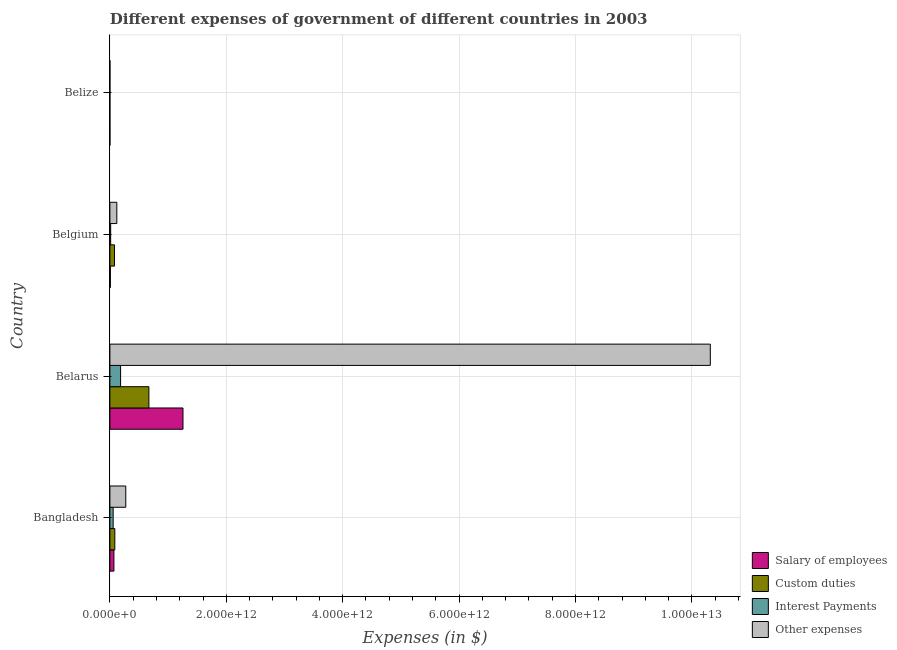How many bars are there on the 2nd tick from the top?
Offer a terse response. 4. What is the label of the 3rd group of bars from the top?
Make the answer very short. Belarus. What is the amount spent on salary of employees in Belize?
Provide a succinct answer. 1.91e+08. Across all countries, what is the maximum amount spent on other expenses?
Keep it short and to the point. 1.03e+13. Across all countries, what is the minimum amount spent on custom duties?
Give a very brief answer. 1.15e+08. In which country was the amount spent on other expenses maximum?
Make the answer very short. Belarus. In which country was the amount spent on custom duties minimum?
Make the answer very short. Belize. What is the total amount spent on other expenses in the graph?
Provide a succinct answer. 1.07e+13. What is the difference between the amount spent on salary of employees in Belarus and that in Belize?
Your answer should be very brief. 1.26e+12. What is the difference between the amount spent on custom duties in Belize and the amount spent on other expenses in Belarus?
Keep it short and to the point. -1.03e+13. What is the average amount spent on salary of employees per country?
Offer a terse response. 3.33e+11. What is the difference between the amount spent on salary of employees and amount spent on custom duties in Belarus?
Provide a succinct answer. 5.86e+11. In how many countries, is the amount spent on salary of employees greater than 2800000000000 $?
Provide a short and direct response. 0. What is the ratio of the amount spent on salary of employees in Belarus to that in Belize?
Make the answer very short. 6583.91. Is the difference between the amount spent on salary of employees in Belarus and Belgium greater than the difference between the amount spent on other expenses in Belarus and Belgium?
Your answer should be compact. No. What is the difference between the highest and the second highest amount spent on salary of employees?
Keep it short and to the point. 1.19e+12. What is the difference between the highest and the lowest amount spent on custom duties?
Your answer should be very brief. 6.70e+11. Is the sum of the amount spent on salary of employees in Bangladesh and Belgium greater than the maximum amount spent on interest payments across all countries?
Make the answer very short. No. What does the 4th bar from the top in Belarus represents?
Offer a terse response. Salary of employees. What does the 4th bar from the bottom in Belize represents?
Provide a succinct answer. Other expenses. Is it the case that in every country, the sum of the amount spent on salary of employees and amount spent on custom duties is greater than the amount spent on interest payments?
Your answer should be very brief. Yes. How many bars are there?
Give a very brief answer. 16. Are all the bars in the graph horizontal?
Keep it short and to the point. Yes. What is the difference between two consecutive major ticks on the X-axis?
Offer a very short reply. 2.00e+12. Does the graph contain any zero values?
Your response must be concise. No. Does the graph contain grids?
Offer a terse response. Yes. Where does the legend appear in the graph?
Make the answer very short. Bottom right. What is the title of the graph?
Provide a short and direct response. Different expenses of government of different countries in 2003. Does "Korea" appear as one of the legend labels in the graph?
Give a very brief answer. No. What is the label or title of the X-axis?
Your response must be concise. Expenses (in $). What is the label or title of the Y-axis?
Your response must be concise. Country. What is the Expenses (in $) in Salary of employees in Bangladesh?
Provide a succinct answer. 6.91e+1. What is the Expenses (in $) in Custom duties in Bangladesh?
Make the answer very short. 8.46e+1. What is the Expenses (in $) of Interest Payments in Bangladesh?
Make the answer very short. 5.62e+1. What is the Expenses (in $) in Other expenses in Bangladesh?
Offer a terse response. 2.73e+11. What is the Expenses (in $) in Salary of employees in Belarus?
Your answer should be very brief. 1.26e+12. What is the Expenses (in $) in Custom duties in Belarus?
Make the answer very short. 6.70e+11. What is the Expenses (in $) of Interest Payments in Belarus?
Provide a short and direct response. 1.84e+11. What is the Expenses (in $) in Other expenses in Belarus?
Your answer should be compact. 1.03e+13. What is the Expenses (in $) of Salary of employees in Belgium?
Keep it short and to the point. 8.32e+09. What is the Expenses (in $) in Custom duties in Belgium?
Provide a succinct answer. 7.95e+1. What is the Expenses (in $) in Interest Payments in Belgium?
Keep it short and to the point. 1.35e+1. What is the Expenses (in $) in Other expenses in Belgium?
Provide a succinct answer. 1.19e+11. What is the Expenses (in $) in Salary of employees in Belize?
Give a very brief answer. 1.91e+08. What is the Expenses (in $) in Custom duties in Belize?
Provide a short and direct response. 1.15e+08. What is the Expenses (in $) of Interest Payments in Belize?
Your answer should be compact. 8.13e+07. What is the Expenses (in $) of Other expenses in Belize?
Provide a short and direct response. 4.78e+08. Across all countries, what is the maximum Expenses (in $) of Salary of employees?
Offer a terse response. 1.26e+12. Across all countries, what is the maximum Expenses (in $) in Custom duties?
Provide a succinct answer. 6.70e+11. Across all countries, what is the maximum Expenses (in $) in Interest Payments?
Your answer should be compact. 1.84e+11. Across all countries, what is the maximum Expenses (in $) of Other expenses?
Provide a short and direct response. 1.03e+13. Across all countries, what is the minimum Expenses (in $) in Salary of employees?
Your answer should be very brief. 1.91e+08. Across all countries, what is the minimum Expenses (in $) of Custom duties?
Your answer should be compact. 1.15e+08. Across all countries, what is the minimum Expenses (in $) in Interest Payments?
Your answer should be very brief. 8.13e+07. Across all countries, what is the minimum Expenses (in $) of Other expenses?
Your answer should be compact. 4.78e+08. What is the total Expenses (in $) of Salary of employees in the graph?
Your response must be concise. 1.33e+12. What is the total Expenses (in $) of Custom duties in the graph?
Provide a short and direct response. 8.34e+11. What is the total Expenses (in $) in Interest Payments in the graph?
Provide a succinct answer. 2.54e+11. What is the total Expenses (in $) in Other expenses in the graph?
Ensure brevity in your answer.  1.07e+13. What is the difference between the Expenses (in $) in Salary of employees in Bangladesh and that in Belarus?
Your answer should be very brief. -1.19e+12. What is the difference between the Expenses (in $) of Custom duties in Bangladesh and that in Belarus?
Your answer should be very brief. -5.86e+11. What is the difference between the Expenses (in $) of Interest Payments in Bangladesh and that in Belarus?
Provide a short and direct response. -1.28e+11. What is the difference between the Expenses (in $) of Other expenses in Bangladesh and that in Belarus?
Provide a succinct answer. -1.00e+13. What is the difference between the Expenses (in $) in Salary of employees in Bangladesh and that in Belgium?
Offer a very short reply. 6.08e+1. What is the difference between the Expenses (in $) in Custom duties in Bangladesh and that in Belgium?
Give a very brief answer. 5.12e+09. What is the difference between the Expenses (in $) in Interest Payments in Bangladesh and that in Belgium?
Keep it short and to the point. 4.26e+1. What is the difference between the Expenses (in $) in Other expenses in Bangladesh and that in Belgium?
Give a very brief answer. 1.54e+11. What is the difference between the Expenses (in $) of Salary of employees in Bangladesh and that in Belize?
Offer a terse response. 6.89e+1. What is the difference between the Expenses (in $) of Custom duties in Bangladesh and that in Belize?
Offer a very short reply. 8.45e+1. What is the difference between the Expenses (in $) of Interest Payments in Bangladesh and that in Belize?
Provide a succinct answer. 5.61e+1. What is the difference between the Expenses (in $) of Other expenses in Bangladesh and that in Belize?
Give a very brief answer. 2.72e+11. What is the difference between the Expenses (in $) in Salary of employees in Belarus and that in Belgium?
Your answer should be compact. 1.25e+12. What is the difference between the Expenses (in $) in Custom duties in Belarus and that in Belgium?
Provide a succinct answer. 5.91e+11. What is the difference between the Expenses (in $) of Interest Payments in Belarus and that in Belgium?
Keep it short and to the point. 1.70e+11. What is the difference between the Expenses (in $) in Other expenses in Belarus and that in Belgium?
Offer a very short reply. 1.02e+13. What is the difference between the Expenses (in $) in Salary of employees in Belarus and that in Belize?
Offer a very short reply. 1.26e+12. What is the difference between the Expenses (in $) in Custom duties in Belarus and that in Belize?
Offer a very short reply. 6.70e+11. What is the difference between the Expenses (in $) in Interest Payments in Belarus and that in Belize?
Offer a very short reply. 1.84e+11. What is the difference between the Expenses (in $) in Other expenses in Belarus and that in Belize?
Your response must be concise. 1.03e+13. What is the difference between the Expenses (in $) of Salary of employees in Belgium and that in Belize?
Provide a succinct answer. 8.13e+09. What is the difference between the Expenses (in $) in Custom duties in Belgium and that in Belize?
Provide a succinct answer. 7.94e+1. What is the difference between the Expenses (in $) in Interest Payments in Belgium and that in Belize?
Your answer should be compact. 1.34e+1. What is the difference between the Expenses (in $) in Other expenses in Belgium and that in Belize?
Provide a succinct answer. 1.19e+11. What is the difference between the Expenses (in $) of Salary of employees in Bangladesh and the Expenses (in $) of Custom duties in Belarus?
Give a very brief answer. -6.01e+11. What is the difference between the Expenses (in $) in Salary of employees in Bangladesh and the Expenses (in $) in Interest Payments in Belarus?
Give a very brief answer. -1.15e+11. What is the difference between the Expenses (in $) of Salary of employees in Bangladesh and the Expenses (in $) of Other expenses in Belarus?
Your answer should be compact. -1.02e+13. What is the difference between the Expenses (in $) of Custom duties in Bangladesh and the Expenses (in $) of Interest Payments in Belarus?
Provide a short and direct response. -9.93e+1. What is the difference between the Expenses (in $) in Custom duties in Bangladesh and the Expenses (in $) in Other expenses in Belarus?
Make the answer very short. -1.02e+13. What is the difference between the Expenses (in $) of Interest Payments in Bangladesh and the Expenses (in $) of Other expenses in Belarus?
Your response must be concise. -1.03e+13. What is the difference between the Expenses (in $) of Salary of employees in Bangladesh and the Expenses (in $) of Custom duties in Belgium?
Keep it short and to the point. -1.04e+1. What is the difference between the Expenses (in $) in Salary of employees in Bangladesh and the Expenses (in $) in Interest Payments in Belgium?
Offer a very short reply. 5.56e+1. What is the difference between the Expenses (in $) of Salary of employees in Bangladesh and the Expenses (in $) of Other expenses in Belgium?
Make the answer very short. -5.02e+1. What is the difference between the Expenses (in $) in Custom duties in Bangladesh and the Expenses (in $) in Interest Payments in Belgium?
Offer a terse response. 7.11e+1. What is the difference between the Expenses (in $) of Custom duties in Bangladesh and the Expenses (in $) of Other expenses in Belgium?
Offer a very short reply. -3.47e+1. What is the difference between the Expenses (in $) of Interest Payments in Bangladesh and the Expenses (in $) of Other expenses in Belgium?
Keep it short and to the point. -6.31e+1. What is the difference between the Expenses (in $) in Salary of employees in Bangladesh and the Expenses (in $) in Custom duties in Belize?
Provide a succinct answer. 6.90e+1. What is the difference between the Expenses (in $) in Salary of employees in Bangladesh and the Expenses (in $) in Interest Payments in Belize?
Ensure brevity in your answer.  6.91e+1. What is the difference between the Expenses (in $) in Salary of employees in Bangladesh and the Expenses (in $) in Other expenses in Belize?
Give a very brief answer. 6.87e+1. What is the difference between the Expenses (in $) of Custom duties in Bangladesh and the Expenses (in $) of Interest Payments in Belize?
Keep it short and to the point. 8.45e+1. What is the difference between the Expenses (in $) in Custom duties in Bangladesh and the Expenses (in $) in Other expenses in Belize?
Ensure brevity in your answer.  8.41e+1. What is the difference between the Expenses (in $) of Interest Payments in Bangladesh and the Expenses (in $) of Other expenses in Belize?
Your answer should be compact. 5.57e+1. What is the difference between the Expenses (in $) in Salary of employees in Belarus and the Expenses (in $) in Custom duties in Belgium?
Make the answer very short. 1.18e+12. What is the difference between the Expenses (in $) of Salary of employees in Belarus and the Expenses (in $) of Interest Payments in Belgium?
Provide a succinct answer. 1.24e+12. What is the difference between the Expenses (in $) in Salary of employees in Belarus and the Expenses (in $) in Other expenses in Belgium?
Offer a very short reply. 1.14e+12. What is the difference between the Expenses (in $) of Custom duties in Belarus and the Expenses (in $) of Interest Payments in Belgium?
Your answer should be very brief. 6.57e+11. What is the difference between the Expenses (in $) of Custom duties in Belarus and the Expenses (in $) of Other expenses in Belgium?
Ensure brevity in your answer.  5.51e+11. What is the difference between the Expenses (in $) in Interest Payments in Belarus and the Expenses (in $) in Other expenses in Belgium?
Your answer should be very brief. 6.46e+1. What is the difference between the Expenses (in $) of Salary of employees in Belarus and the Expenses (in $) of Custom duties in Belize?
Provide a succinct answer. 1.26e+12. What is the difference between the Expenses (in $) of Salary of employees in Belarus and the Expenses (in $) of Interest Payments in Belize?
Provide a succinct answer. 1.26e+12. What is the difference between the Expenses (in $) in Salary of employees in Belarus and the Expenses (in $) in Other expenses in Belize?
Your response must be concise. 1.26e+12. What is the difference between the Expenses (in $) of Custom duties in Belarus and the Expenses (in $) of Interest Payments in Belize?
Your response must be concise. 6.70e+11. What is the difference between the Expenses (in $) of Custom duties in Belarus and the Expenses (in $) of Other expenses in Belize?
Keep it short and to the point. 6.70e+11. What is the difference between the Expenses (in $) in Interest Payments in Belarus and the Expenses (in $) in Other expenses in Belize?
Your answer should be compact. 1.83e+11. What is the difference between the Expenses (in $) of Salary of employees in Belgium and the Expenses (in $) of Custom duties in Belize?
Provide a short and direct response. 8.21e+09. What is the difference between the Expenses (in $) of Salary of employees in Belgium and the Expenses (in $) of Interest Payments in Belize?
Offer a very short reply. 8.24e+09. What is the difference between the Expenses (in $) of Salary of employees in Belgium and the Expenses (in $) of Other expenses in Belize?
Provide a succinct answer. 7.84e+09. What is the difference between the Expenses (in $) in Custom duties in Belgium and the Expenses (in $) in Interest Payments in Belize?
Make the answer very short. 7.94e+1. What is the difference between the Expenses (in $) in Custom duties in Belgium and the Expenses (in $) in Other expenses in Belize?
Provide a succinct answer. 7.90e+1. What is the difference between the Expenses (in $) in Interest Payments in Belgium and the Expenses (in $) in Other expenses in Belize?
Ensure brevity in your answer.  1.30e+1. What is the average Expenses (in $) in Salary of employees per country?
Your answer should be compact. 3.33e+11. What is the average Expenses (in $) in Custom duties per country?
Provide a short and direct response. 2.09e+11. What is the average Expenses (in $) in Interest Payments per country?
Provide a succinct answer. 6.34e+1. What is the average Expenses (in $) of Other expenses per country?
Provide a succinct answer. 2.68e+12. What is the difference between the Expenses (in $) in Salary of employees and Expenses (in $) in Custom duties in Bangladesh?
Your answer should be very brief. -1.55e+1. What is the difference between the Expenses (in $) of Salary of employees and Expenses (in $) of Interest Payments in Bangladesh?
Provide a short and direct response. 1.30e+1. What is the difference between the Expenses (in $) in Salary of employees and Expenses (in $) in Other expenses in Bangladesh?
Ensure brevity in your answer.  -2.04e+11. What is the difference between the Expenses (in $) of Custom duties and Expenses (in $) of Interest Payments in Bangladesh?
Ensure brevity in your answer.  2.85e+1. What is the difference between the Expenses (in $) of Custom duties and Expenses (in $) of Other expenses in Bangladesh?
Your response must be concise. -1.88e+11. What is the difference between the Expenses (in $) in Interest Payments and Expenses (in $) in Other expenses in Bangladesh?
Your answer should be compact. -2.17e+11. What is the difference between the Expenses (in $) in Salary of employees and Expenses (in $) in Custom duties in Belarus?
Provide a succinct answer. 5.86e+11. What is the difference between the Expenses (in $) of Salary of employees and Expenses (in $) of Interest Payments in Belarus?
Ensure brevity in your answer.  1.07e+12. What is the difference between the Expenses (in $) in Salary of employees and Expenses (in $) in Other expenses in Belarus?
Ensure brevity in your answer.  -9.06e+12. What is the difference between the Expenses (in $) in Custom duties and Expenses (in $) in Interest Payments in Belarus?
Keep it short and to the point. 4.86e+11. What is the difference between the Expenses (in $) of Custom duties and Expenses (in $) of Other expenses in Belarus?
Make the answer very short. -9.65e+12. What is the difference between the Expenses (in $) of Interest Payments and Expenses (in $) of Other expenses in Belarus?
Your answer should be very brief. -1.01e+13. What is the difference between the Expenses (in $) in Salary of employees and Expenses (in $) in Custom duties in Belgium?
Keep it short and to the point. -7.12e+1. What is the difference between the Expenses (in $) in Salary of employees and Expenses (in $) in Interest Payments in Belgium?
Give a very brief answer. -5.19e+09. What is the difference between the Expenses (in $) of Salary of employees and Expenses (in $) of Other expenses in Belgium?
Ensure brevity in your answer.  -1.11e+11. What is the difference between the Expenses (in $) in Custom duties and Expenses (in $) in Interest Payments in Belgium?
Keep it short and to the point. 6.60e+1. What is the difference between the Expenses (in $) in Custom duties and Expenses (in $) in Other expenses in Belgium?
Make the answer very short. -3.98e+1. What is the difference between the Expenses (in $) of Interest Payments and Expenses (in $) of Other expenses in Belgium?
Provide a short and direct response. -1.06e+11. What is the difference between the Expenses (in $) in Salary of employees and Expenses (in $) in Custom duties in Belize?
Your answer should be very brief. 7.56e+07. What is the difference between the Expenses (in $) of Salary of employees and Expenses (in $) of Interest Payments in Belize?
Your response must be concise. 1.09e+08. What is the difference between the Expenses (in $) of Salary of employees and Expenses (in $) of Other expenses in Belize?
Provide a short and direct response. -2.87e+08. What is the difference between the Expenses (in $) of Custom duties and Expenses (in $) of Interest Payments in Belize?
Ensure brevity in your answer.  3.38e+07. What is the difference between the Expenses (in $) in Custom duties and Expenses (in $) in Other expenses in Belize?
Your response must be concise. -3.63e+08. What is the difference between the Expenses (in $) in Interest Payments and Expenses (in $) in Other expenses in Belize?
Give a very brief answer. -3.96e+08. What is the ratio of the Expenses (in $) in Salary of employees in Bangladesh to that in Belarus?
Your answer should be very brief. 0.06. What is the ratio of the Expenses (in $) in Custom duties in Bangladesh to that in Belarus?
Your answer should be compact. 0.13. What is the ratio of the Expenses (in $) of Interest Payments in Bangladesh to that in Belarus?
Make the answer very short. 0.31. What is the ratio of the Expenses (in $) in Other expenses in Bangladesh to that in Belarus?
Make the answer very short. 0.03. What is the ratio of the Expenses (in $) in Salary of employees in Bangladesh to that in Belgium?
Your answer should be compact. 8.31. What is the ratio of the Expenses (in $) in Custom duties in Bangladesh to that in Belgium?
Your response must be concise. 1.06. What is the ratio of the Expenses (in $) in Interest Payments in Bangladesh to that in Belgium?
Provide a short and direct response. 4.16. What is the ratio of the Expenses (in $) in Other expenses in Bangladesh to that in Belgium?
Keep it short and to the point. 2.29. What is the ratio of the Expenses (in $) of Salary of employees in Bangladesh to that in Belize?
Your answer should be very brief. 362.49. What is the ratio of the Expenses (in $) of Custom duties in Bangladesh to that in Belize?
Your answer should be compact. 734.72. What is the ratio of the Expenses (in $) of Interest Payments in Bangladesh to that in Belize?
Provide a succinct answer. 690.47. What is the ratio of the Expenses (in $) of Other expenses in Bangladesh to that in Belize?
Offer a very short reply. 571.24. What is the ratio of the Expenses (in $) of Salary of employees in Belarus to that in Belgium?
Your response must be concise. 150.91. What is the ratio of the Expenses (in $) in Custom duties in Belarus to that in Belgium?
Your answer should be very brief. 8.43. What is the ratio of the Expenses (in $) in Interest Payments in Belarus to that in Belgium?
Offer a terse response. 13.61. What is the ratio of the Expenses (in $) of Other expenses in Belarus to that in Belgium?
Provide a short and direct response. 86.47. What is the ratio of the Expenses (in $) of Salary of employees in Belarus to that in Belize?
Make the answer very short. 6583.91. What is the ratio of the Expenses (in $) in Custom duties in Belarus to that in Belize?
Give a very brief answer. 5819. What is the ratio of the Expenses (in $) of Interest Payments in Belarus to that in Belize?
Give a very brief answer. 2261.66. What is the ratio of the Expenses (in $) of Other expenses in Belarus to that in Belize?
Ensure brevity in your answer.  2.16e+04. What is the ratio of the Expenses (in $) in Salary of employees in Belgium to that in Belize?
Offer a very short reply. 43.63. What is the ratio of the Expenses (in $) of Custom duties in Belgium to that in Belize?
Your answer should be very brief. 690.29. What is the ratio of the Expenses (in $) in Interest Payments in Belgium to that in Belize?
Offer a terse response. 166.16. What is the ratio of the Expenses (in $) in Other expenses in Belgium to that in Belize?
Give a very brief answer. 249.69. What is the difference between the highest and the second highest Expenses (in $) of Salary of employees?
Offer a very short reply. 1.19e+12. What is the difference between the highest and the second highest Expenses (in $) of Custom duties?
Make the answer very short. 5.86e+11. What is the difference between the highest and the second highest Expenses (in $) in Interest Payments?
Provide a succinct answer. 1.28e+11. What is the difference between the highest and the second highest Expenses (in $) of Other expenses?
Your answer should be compact. 1.00e+13. What is the difference between the highest and the lowest Expenses (in $) in Salary of employees?
Offer a terse response. 1.26e+12. What is the difference between the highest and the lowest Expenses (in $) of Custom duties?
Provide a succinct answer. 6.70e+11. What is the difference between the highest and the lowest Expenses (in $) of Interest Payments?
Offer a very short reply. 1.84e+11. What is the difference between the highest and the lowest Expenses (in $) of Other expenses?
Make the answer very short. 1.03e+13. 